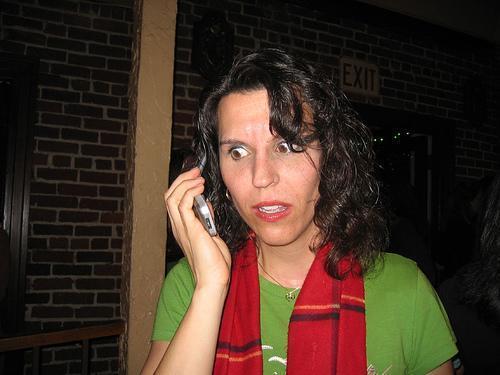How many people are in the picture?
Give a very brief answer. 1. How many colors does this womans scarf have?
Give a very brief answer. 3. 